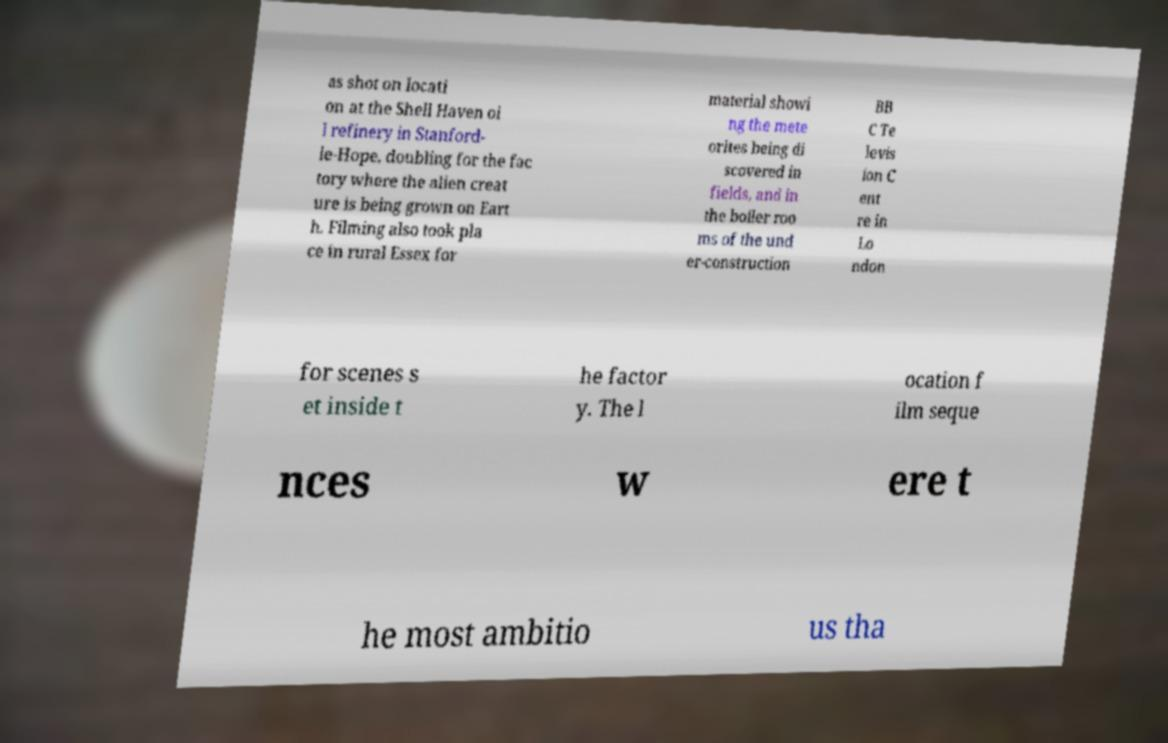For documentation purposes, I need the text within this image transcribed. Could you provide that? as shot on locati on at the Shell Haven oi l refinery in Stanford- le-Hope, doubling for the fac tory where the alien creat ure is being grown on Eart h. Filming also took pla ce in rural Essex for material showi ng the mete orites being di scovered in fields, and in the boiler roo ms of the und er-construction BB C Te levis ion C ent re in Lo ndon for scenes s et inside t he factor y. The l ocation f ilm seque nces w ere t he most ambitio us tha 